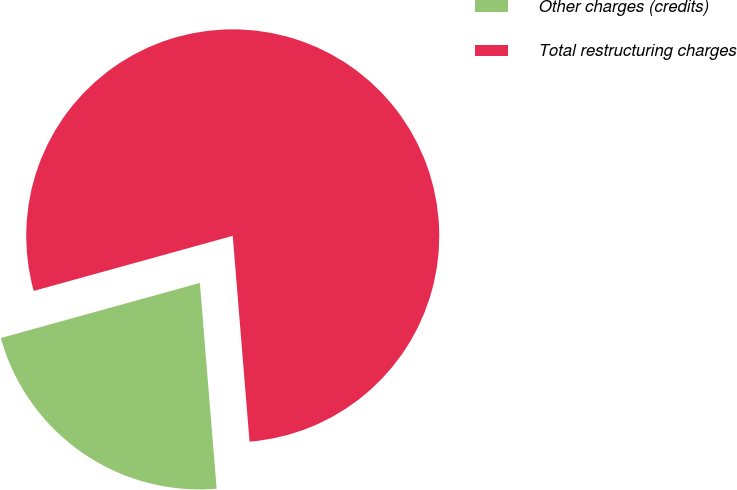<chart> <loc_0><loc_0><loc_500><loc_500><pie_chart><fcel>Other charges (credits)<fcel>Total restructuring charges<nl><fcel>22.0%<fcel>78.0%<nl></chart> 